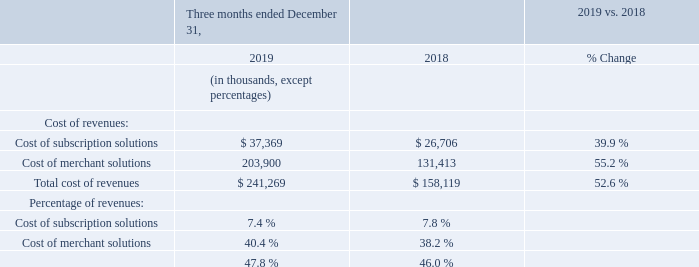Cost of Revenues
Cost of Subscription Solutions
Cost of subscription solutions increased $10.7 million, or 39.9%, for the three months ended December 31, 2019 compared to the same period in 2018. The increase was due to an increase in the costs necessary to support a greater number of merchants using our platform, resulting in an increase in: infrastructure and hosting costs, employee-related costs, credit card fees for processing merchant billings, amortization of technology related to enhancing our platform, payments to third-party partners for the registration of domain names, and payments to third-party theme developers. As a percentage of revenues, cost of subscription solutions decreased from 7.8% in the three months ended December 31, 2018 to 7.4% in the three months ended December 31, 2019 due to subscription solutions representing a smaller percentage of our total revenues.
Cost of Merchant Solutions
Cost of merchant solutions increased $72.5 million, or 55.2%, for the three months ended December 31, 2019 compared to the same period in 2018. The increase was primarily due to higher payment processing and interchange fees resulting from an increase in GMV facilitated through Shopify Payments. The increase was also due to an increase in amortization related to acquired intangibles from the acquisition of 6RS, employee-related costs associated with 6RS, product costs associated with expanding our product offerings, credit card fees for processing merchant billings, infrastructure and hosting costs, materials and third-party manufacturing costs associated with 6RS and cost of POS hardware units. Cost of merchant solutions as a percentage of revenues increased from 38.2% in the three months ended December 31, 2018 to 40.4% in the three months ended December 31, 2019, mainly as a result of Shopify Payments representing a larger percentage of total revenue.
How much is the cost of subscriptions solutions revenue for both financial year ends (in chronological order)?
Answer scale should be: thousand. $ 26,706, $ 37,369. How much is the cost of merchant solutions revenue for both financial year ends (in chronological order)?
Answer scale should be: thousand. 131,413, 203,900. How much is the total cost of revenues for both financial year ends (in chronological order)?
Answer scale should be: thousand. $ 158,119, $ 241,269. Between 2018 and 2019 year end, which year's cost of subscriptions solutions constitutes a higher percentage of revenues? 7.8 %>7.4 %
Answer: 2018. Between 2018 and 2019 year end, which year's cost of merchant solutions constitues a higher percentage of total revenues? 40.4 %>38.2 %
Answer: 2019. Between 2018 and 2019 year end, which year had a higher total cost of revenues? $ 241,269>$ 158,119
Answer: 2019. 